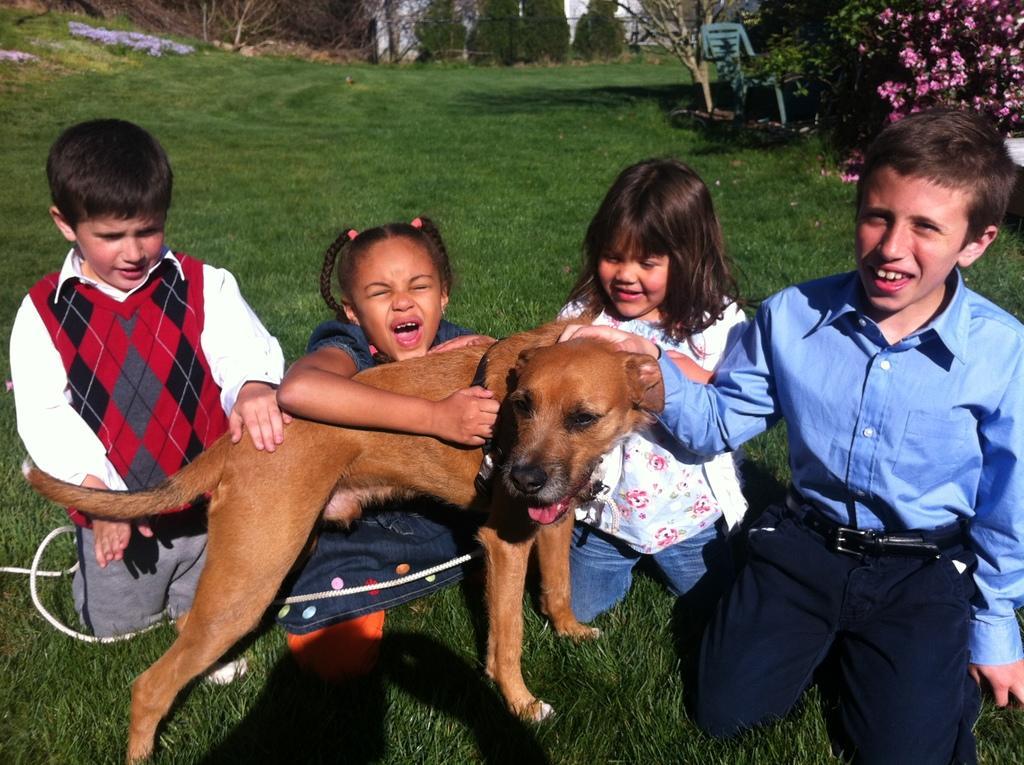Describe this image in one or two sentences. These 4 kids are sitting on a grass. In-front of these kids there is a dog. This girl is holding a dog. Far there are plants with flowers. This is chair. Grass is in green color. 